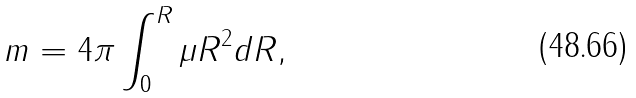<formula> <loc_0><loc_0><loc_500><loc_500>m = 4 \pi \int ^ { R } _ { 0 } \mu R ^ { 2 } d R ,</formula> 